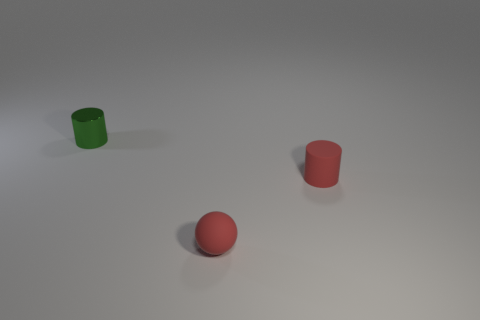Can you tell me what materials these objects might be made of based on their appearance? The objects in the image appear to have a matte finish, suggesting that they could be made of a solid material like plastic. The lack of shine or reflections typically indicates a non-metallic, non-glossy surface, consistent with common rubber or plastic materials used for toys or simple household items. 